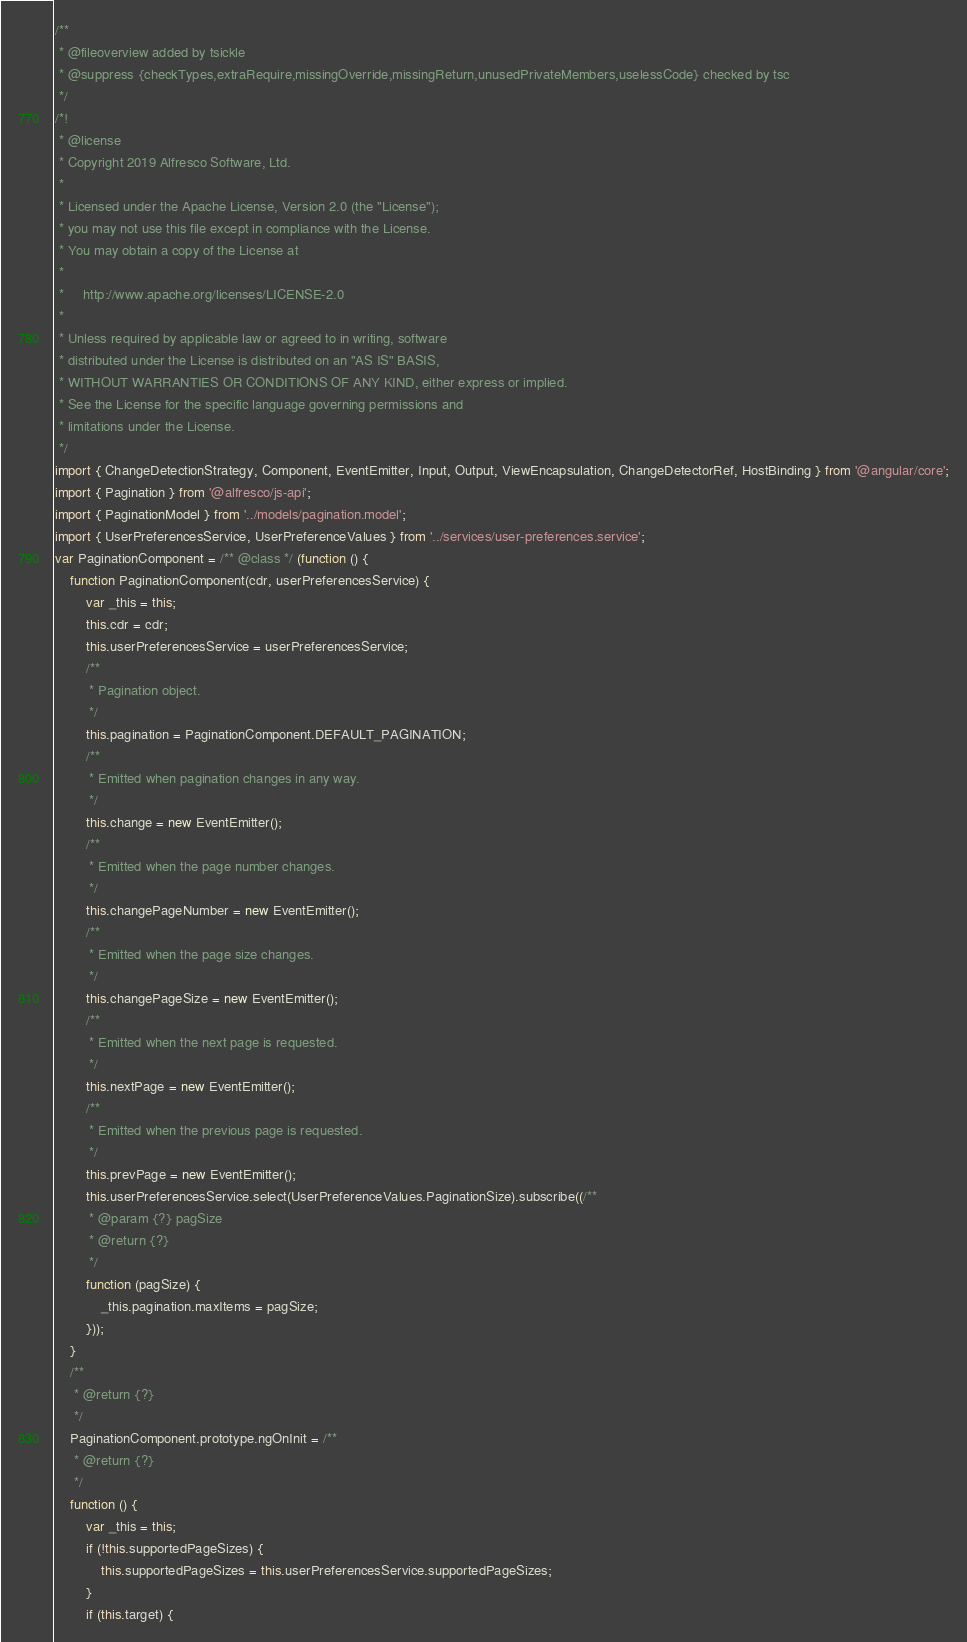Convert code to text. <code><loc_0><loc_0><loc_500><loc_500><_JavaScript_>/**
 * @fileoverview added by tsickle
 * @suppress {checkTypes,extraRequire,missingOverride,missingReturn,unusedPrivateMembers,uselessCode} checked by tsc
 */
/*!
 * @license
 * Copyright 2019 Alfresco Software, Ltd.
 *
 * Licensed under the Apache License, Version 2.0 (the "License");
 * you may not use this file except in compliance with the License.
 * You may obtain a copy of the License at
 *
 *     http://www.apache.org/licenses/LICENSE-2.0
 *
 * Unless required by applicable law or agreed to in writing, software
 * distributed under the License is distributed on an "AS IS" BASIS,
 * WITHOUT WARRANTIES OR CONDITIONS OF ANY KIND, either express or implied.
 * See the License for the specific language governing permissions and
 * limitations under the License.
 */
import { ChangeDetectionStrategy, Component, EventEmitter, Input, Output, ViewEncapsulation, ChangeDetectorRef, HostBinding } from '@angular/core';
import { Pagination } from '@alfresco/js-api';
import { PaginationModel } from '../models/pagination.model';
import { UserPreferencesService, UserPreferenceValues } from '../services/user-preferences.service';
var PaginationComponent = /** @class */ (function () {
    function PaginationComponent(cdr, userPreferencesService) {
        var _this = this;
        this.cdr = cdr;
        this.userPreferencesService = userPreferencesService;
        /**
         * Pagination object.
         */
        this.pagination = PaginationComponent.DEFAULT_PAGINATION;
        /**
         * Emitted when pagination changes in any way.
         */
        this.change = new EventEmitter();
        /**
         * Emitted when the page number changes.
         */
        this.changePageNumber = new EventEmitter();
        /**
         * Emitted when the page size changes.
         */
        this.changePageSize = new EventEmitter();
        /**
         * Emitted when the next page is requested.
         */
        this.nextPage = new EventEmitter();
        /**
         * Emitted when the previous page is requested.
         */
        this.prevPage = new EventEmitter();
        this.userPreferencesService.select(UserPreferenceValues.PaginationSize).subscribe((/**
         * @param {?} pagSize
         * @return {?}
         */
        function (pagSize) {
            _this.pagination.maxItems = pagSize;
        }));
    }
    /**
     * @return {?}
     */
    PaginationComponent.prototype.ngOnInit = /**
     * @return {?}
     */
    function () {
        var _this = this;
        if (!this.supportedPageSizes) {
            this.supportedPageSizes = this.userPreferencesService.supportedPageSizes;
        }
        if (this.target) {</code> 